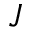<formula> <loc_0><loc_0><loc_500><loc_500>J</formula> 